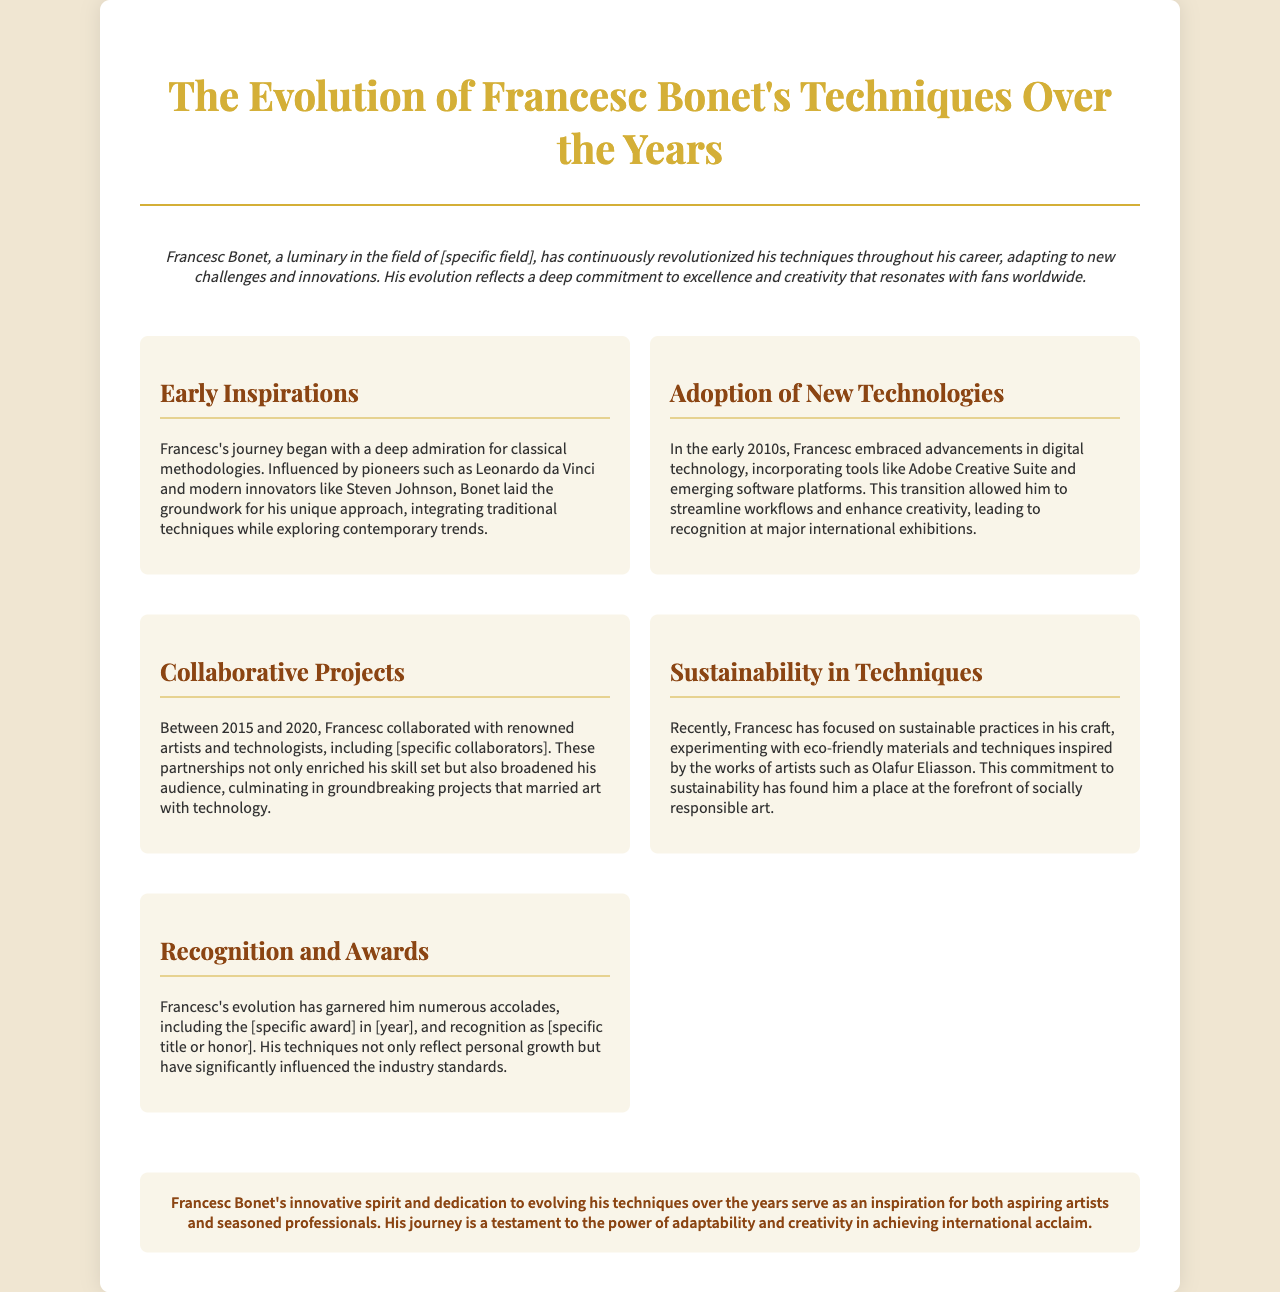What is the title of the brochure? The title is clearly stated at the top of the document within the header section.
Answer: The Evolution of Francesc Bonet's Techniques Over the Years Who are some of Francesc's early inspirations? The document mentions specific historical figures that have influenced Francesc's techniques.
Answer: Leonardo da Vinci and Steven Johnson What significant technological advancements did Francesc adopt in the early 2010s? The section discusses the tools Francesc embraced to enhance his creative process during that time.
Answer: Adobe Creative Suite What years mark Francesc's collaborative projects? The document specifies a range of years when these collaborations took place, reflecting Francesc's timeline of work.
Answer: 2015 to 2020 What recent focus has Francesc highlighted in his techniques? The document elaborates on a specific area of sustainability that Francesc has committed to in his craft.
Answer: Sustainable practices What accolade did Francesc receive in the brochure? The document mentions a notable award that Francesc earned, emphasizing his recognition in the field.
Answer: [specific award] What is the concluding sentiment about Francesc's journey in the document? The conclusion provides an overview of the inspiration derived from Francesc's evolution and its impact on others.
Answer: An inspiration for both aspiring artists and seasoned professionals 